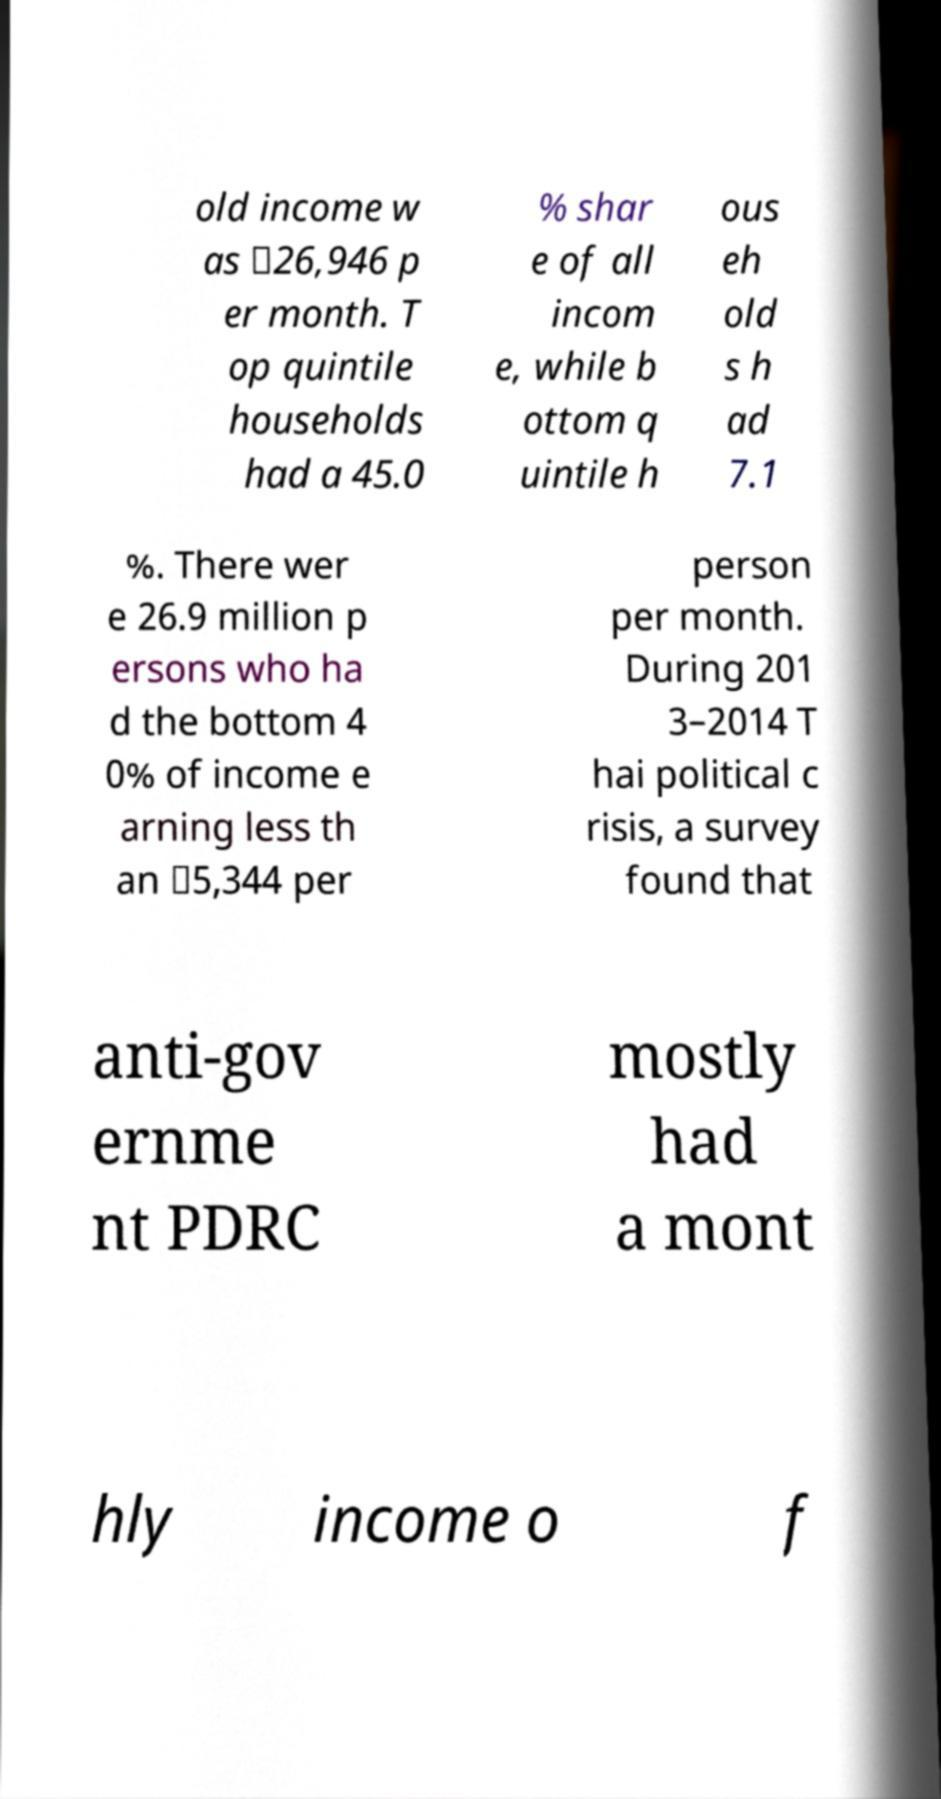There's text embedded in this image that I need extracted. Can you transcribe it verbatim? old income w as ฿26,946 p er month. T op quintile households had a 45.0 % shar e of all incom e, while b ottom q uintile h ous eh old s h ad 7.1 %. There wer e 26.9 million p ersons who ha d the bottom 4 0% of income e arning less th an ฿5,344 per person per month. During 201 3–2014 T hai political c risis, a survey found that anti-gov ernme nt PDRC mostly had a mont hly income o f 